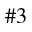<formula> <loc_0><loc_0><loc_500><loc_500>\# 3</formula> 